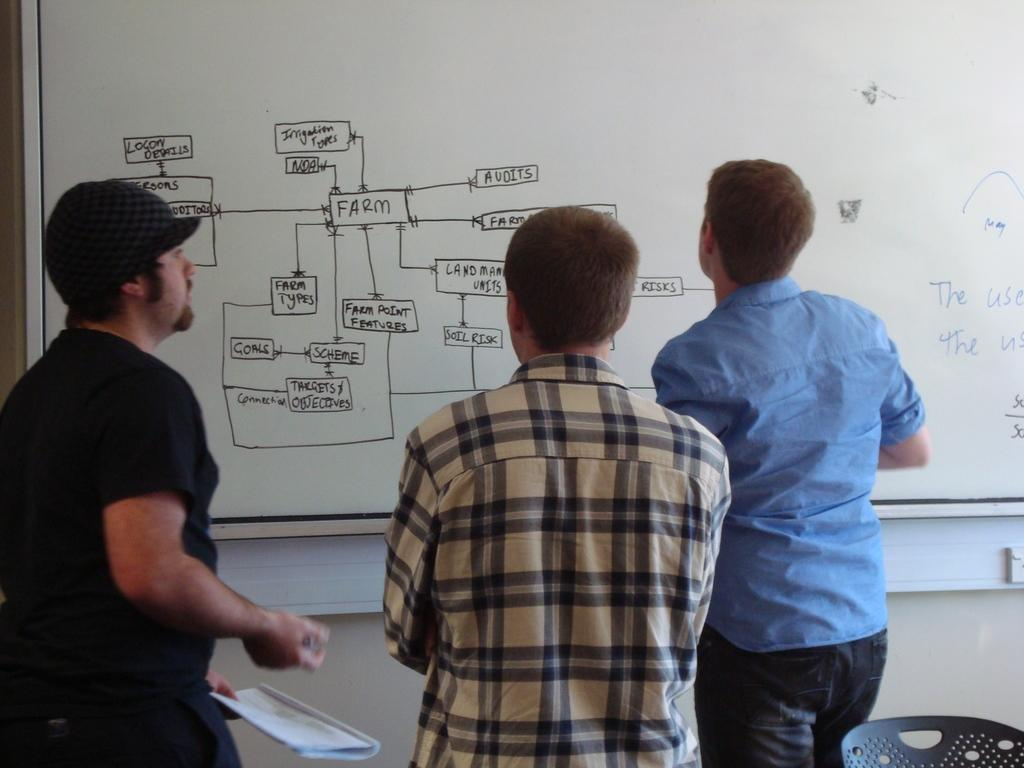<image>
Write a terse but informative summary of the picture. Three students stand in front of a whiteboard discussing Farm features shown in a diagram. 